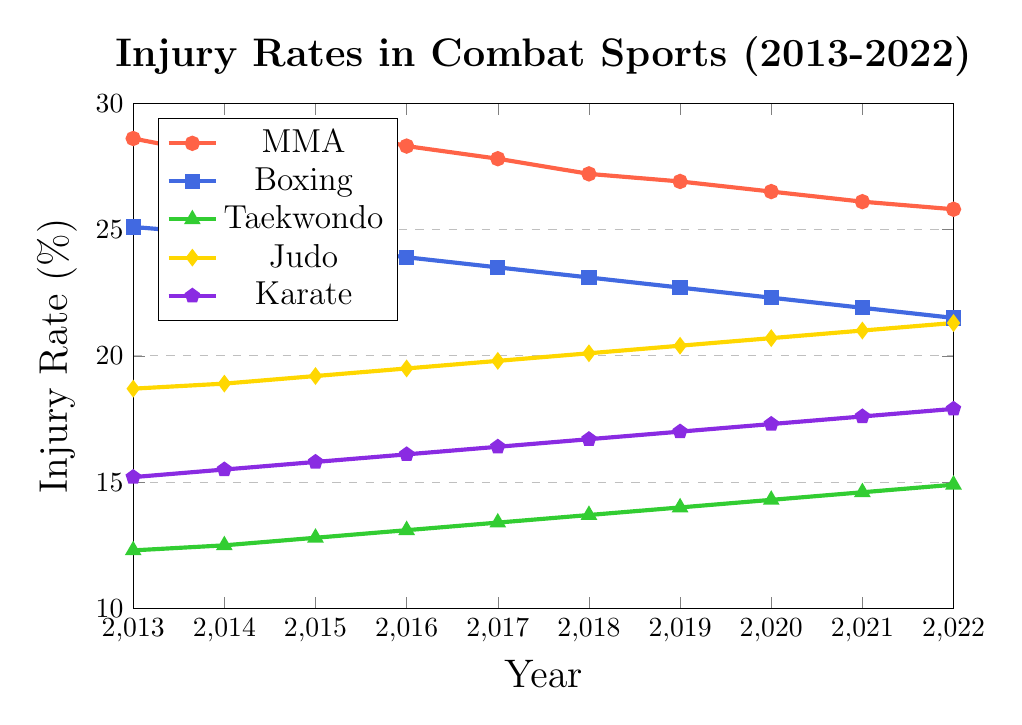What is the highest injury rate for MMA in the last 10 years? To find the highest injury rate for MMA, look at the values for MMA from 2013 to 2022. The highest value is 29.1% in 2015.
Answer: 29.1% What was the difference in the injury rate for Boxing between 2013 and 2022? Subtract the injury rate for Boxing in 2022 (21.5%) from that in 2013 (25.1%). The difference is 25.1% - 21.5% = 3.6%.
Answer: 3.6% Which combat sport had the lowest injury rate in 2022? Compare the injury rates of all combat sports in 2022. Taekwondo had the lowest rate at 14.9%.
Answer: Taekwondo How did the injury rate for Judo change from 2013 to 2022? Identify the injury rates for Judo in 2013 (18.7%) and in 2022 (21.3%). Subtract the 2013 rate from the 2022 rate to find the change: 21.3% - 18.7% = 2.6%. The injury rate increased by 2.6%.
Answer: Increased by 2.6% What is the overall trend for the injury rate in MMA from 2013 to 2022? Observing the trend of MMA, the rates started high in 2013 (28.6%) and gradually decreased over time to 25.8% in 2022. The trend is generally downward.
Answer: Downward trend Which sport had the highest increase in injury rate from 2013 to 2022? Calculate the change for each sport: MMA (28.6 to 25.8 = decrease), Boxing (25.1 to 21.5 = decrease), Taekwondo (12.3 to 14.9 = increase), Judo (18.7 to 21.3 = increase), Karate (15.2 to 17.9 = increase). The highest increase is for Judo with an increase of 2.6%.
Answer: Judo In which year did the injury rate for Karate surpass 17%? Find the point in the data where Karate's injury rate first exceeds 17%. In 2019, the rate was 17.0%, so it surpassed 17% in 2020 with 17.3%.
Answer: 2020 Which combat sport had the most consistent injury rate over the 10 years? To determine consistency, look at how the rates fluctuated for each sport. Taekwondo shows a gradual increase with small changes and no significant spikes, indicating it had the most consistent rate.
Answer: Taekwondo Did any sport have a marked increase in injury rate over the given period? To spot marked increases, look for a combat sport whose injury rate significantly rose over the years. Judo's injury rate increased steadily from 18.7% in 2013 to 21.3% in 2022.
Answer: Judo 